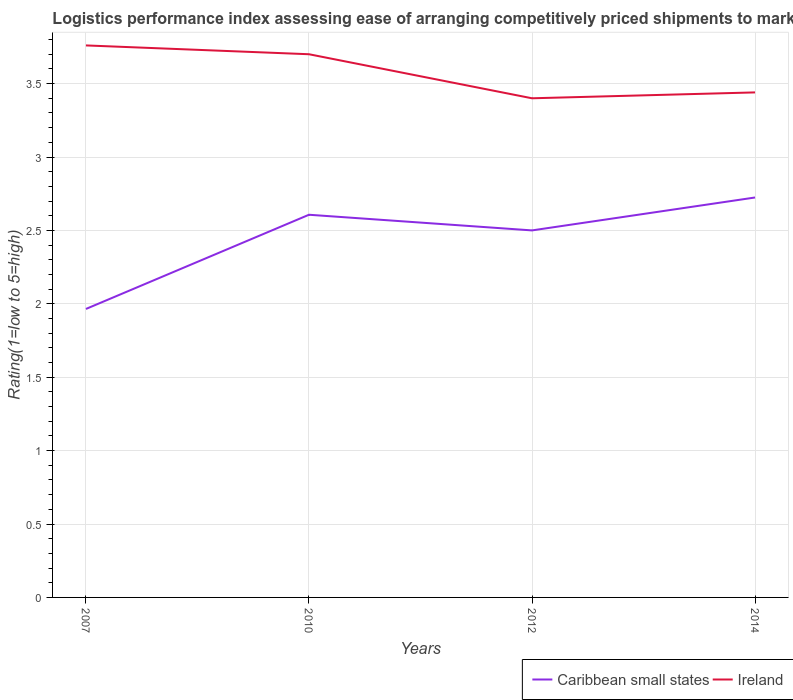Is the number of lines equal to the number of legend labels?
Keep it short and to the point. Yes. What is the total Logistic performance index in Ireland in the graph?
Provide a succinct answer. -0.04. What is the difference between the highest and the second highest Logistic performance index in Caribbean small states?
Your answer should be very brief. 0.76. What is the difference between the highest and the lowest Logistic performance index in Ireland?
Keep it short and to the point. 2. How many lines are there?
Provide a succinct answer. 2. How many years are there in the graph?
Your response must be concise. 4. What is the difference between two consecutive major ticks on the Y-axis?
Provide a short and direct response. 0.5. Does the graph contain any zero values?
Provide a succinct answer. No. Does the graph contain grids?
Provide a succinct answer. Yes. Where does the legend appear in the graph?
Provide a succinct answer. Bottom right. How many legend labels are there?
Your answer should be very brief. 2. How are the legend labels stacked?
Give a very brief answer. Horizontal. What is the title of the graph?
Ensure brevity in your answer.  Logistics performance index assessing ease of arranging competitively priced shipments to markets. Does "Hungary" appear as one of the legend labels in the graph?
Offer a very short reply. No. What is the label or title of the Y-axis?
Provide a succinct answer. Rating(1=low to 5=high). What is the Rating(1=low to 5=high) of Caribbean small states in 2007?
Your answer should be compact. 1.97. What is the Rating(1=low to 5=high) of Ireland in 2007?
Keep it short and to the point. 3.76. What is the Rating(1=low to 5=high) in Caribbean small states in 2010?
Offer a terse response. 2.61. What is the Rating(1=low to 5=high) in Caribbean small states in 2014?
Ensure brevity in your answer.  2.72. What is the Rating(1=low to 5=high) in Ireland in 2014?
Ensure brevity in your answer.  3.44. Across all years, what is the maximum Rating(1=low to 5=high) in Caribbean small states?
Your answer should be very brief. 2.72. Across all years, what is the maximum Rating(1=low to 5=high) in Ireland?
Keep it short and to the point. 3.76. Across all years, what is the minimum Rating(1=low to 5=high) in Caribbean small states?
Offer a terse response. 1.97. Across all years, what is the minimum Rating(1=low to 5=high) in Ireland?
Your response must be concise. 3.4. What is the total Rating(1=low to 5=high) of Caribbean small states in the graph?
Make the answer very short. 9.8. What is the total Rating(1=low to 5=high) of Ireland in the graph?
Make the answer very short. 14.3. What is the difference between the Rating(1=low to 5=high) of Caribbean small states in 2007 and that in 2010?
Your answer should be very brief. -0.64. What is the difference between the Rating(1=low to 5=high) of Ireland in 2007 and that in 2010?
Provide a succinct answer. 0.06. What is the difference between the Rating(1=low to 5=high) of Caribbean small states in 2007 and that in 2012?
Make the answer very short. -0.54. What is the difference between the Rating(1=low to 5=high) in Ireland in 2007 and that in 2012?
Give a very brief answer. 0.36. What is the difference between the Rating(1=low to 5=high) in Caribbean small states in 2007 and that in 2014?
Provide a short and direct response. -0.76. What is the difference between the Rating(1=low to 5=high) in Ireland in 2007 and that in 2014?
Your answer should be very brief. 0.32. What is the difference between the Rating(1=low to 5=high) of Caribbean small states in 2010 and that in 2012?
Make the answer very short. 0.11. What is the difference between the Rating(1=low to 5=high) of Caribbean small states in 2010 and that in 2014?
Keep it short and to the point. -0.12. What is the difference between the Rating(1=low to 5=high) of Ireland in 2010 and that in 2014?
Your response must be concise. 0.26. What is the difference between the Rating(1=low to 5=high) in Caribbean small states in 2012 and that in 2014?
Offer a very short reply. -0.22. What is the difference between the Rating(1=low to 5=high) of Ireland in 2012 and that in 2014?
Make the answer very short. -0.04. What is the difference between the Rating(1=low to 5=high) of Caribbean small states in 2007 and the Rating(1=low to 5=high) of Ireland in 2010?
Provide a succinct answer. -1.74. What is the difference between the Rating(1=low to 5=high) of Caribbean small states in 2007 and the Rating(1=low to 5=high) of Ireland in 2012?
Provide a succinct answer. -1.44. What is the difference between the Rating(1=low to 5=high) of Caribbean small states in 2007 and the Rating(1=low to 5=high) of Ireland in 2014?
Make the answer very short. -1.48. What is the difference between the Rating(1=low to 5=high) in Caribbean small states in 2010 and the Rating(1=low to 5=high) in Ireland in 2012?
Keep it short and to the point. -0.79. What is the difference between the Rating(1=low to 5=high) in Caribbean small states in 2012 and the Rating(1=low to 5=high) in Ireland in 2014?
Provide a short and direct response. -0.94. What is the average Rating(1=low to 5=high) in Caribbean small states per year?
Make the answer very short. 2.45. What is the average Rating(1=low to 5=high) of Ireland per year?
Ensure brevity in your answer.  3.58. In the year 2007, what is the difference between the Rating(1=low to 5=high) in Caribbean small states and Rating(1=low to 5=high) in Ireland?
Your answer should be compact. -1.79. In the year 2010, what is the difference between the Rating(1=low to 5=high) in Caribbean small states and Rating(1=low to 5=high) in Ireland?
Make the answer very short. -1.09. In the year 2012, what is the difference between the Rating(1=low to 5=high) in Caribbean small states and Rating(1=low to 5=high) in Ireland?
Your answer should be compact. -0.9. In the year 2014, what is the difference between the Rating(1=low to 5=high) in Caribbean small states and Rating(1=low to 5=high) in Ireland?
Keep it short and to the point. -0.72. What is the ratio of the Rating(1=low to 5=high) of Caribbean small states in 2007 to that in 2010?
Your answer should be compact. 0.75. What is the ratio of the Rating(1=low to 5=high) in Ireland in 2007 to that in 2010?
Offer a terse response. 1.02. What is the ratio of the Rating(1=low to 5=high) of Caribbean small states in 2007 to that in 2012?
Offer a very short reply. 0.79. What is the ratio of the Rating(1=low to 5=high) in Ireland in 2007 to that in 2012?
Keep it short and to the point. 1.11. What is the ratio of the Rating(1=low to 5=high) of Caribbean small states in 2007 to that in 2014?
Your answer should be compact. 0.72. What is the ratio of the Rating(1=low to 5=high) of Ireland in 2007 to that in 2014?
Keep it short and to the point. 1.09. What is the ratio of the Rating(1=low to 5=high) in Caribbean small states in 2010 to that in 2012?
Ensure brevity in your answer.  1.04. What is the ratio of the Rating(1=low to 5=high) of Ireland in 2010 to that in 2012?
Provide a succinct answer. 1.09. What is the ratio of the Rating(1=low to 5=high) of Caribbean small states in 2010 to that in 2014?
Keep it short and to the point. 0.96. What is the ratio of the Rating(1=low to 5=high) in Ireland in 2010 to that in 2014?
Keep it short and to the point. 1.08. What is the ratio of the Rating(1=low to 5=high) of Caribbean small states in 2012 to that in 2014?
Provide a short and direct response. 0.92. What is the ratio of the Rating(1=low to 5=high) in Ireland in 2012 to that in 2014?
Your response must be concise. 0.99. What is the difference between the highest and the second highest Rating(1=low to 5=high) in Caribbean small states?
Ensure brevity in your answer.  0.12. What is the difference between the highest and the lowest Rating(1=low to 5=high) of Caribbean small states?
Keep it short and to the point. 0.76. What is the difference between the highest and the lowest Rating(1=low to 5=high) in Ireland?
Offer a very short reply. 0.36. 